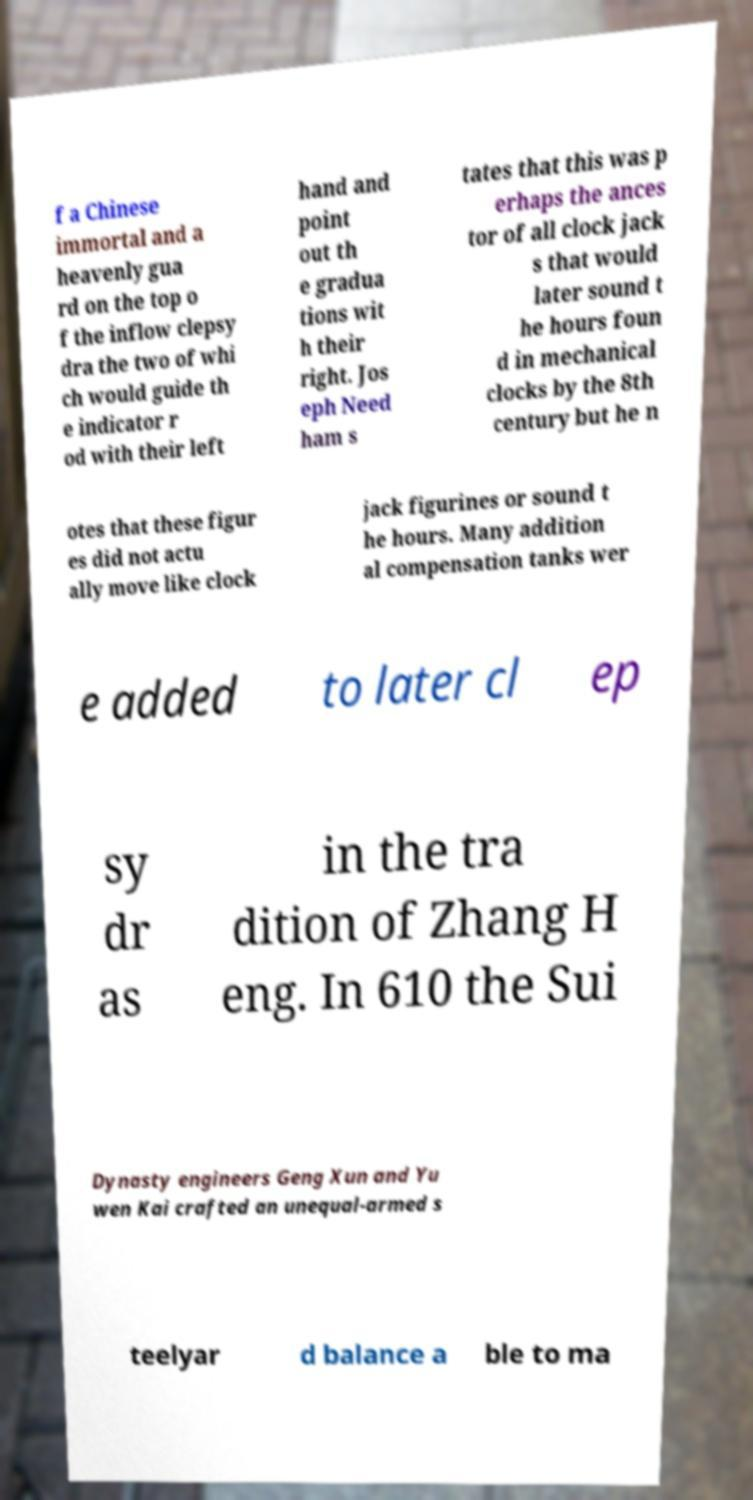What messages or text are displayed in this image? I need them in a readable, typed format. f a Chinese immortal and a heavenly gua rd on the top o f the inflow clepsy dra the two of whi ch would guide th e indicator r od with their left hand and point out th e gradua tions wit h their right. Jos eph Need ham s tates that this was p erhaps the ances tor of all clock jack s that would later sound t he hours foun d in mechanical clocks by the 8th century but he n otes that these figur es did not actu ally move like clock jack figurines or sound t he hours. Many addition al compensation tanks wer e added to later cl ep sy dr as in the tra dition of Zhang H eng. In 610 the Sui Dynasty engineers Geng Xun and Yu wen Kai crafted an unequal-armed s teelyar d balance a ble to ma 